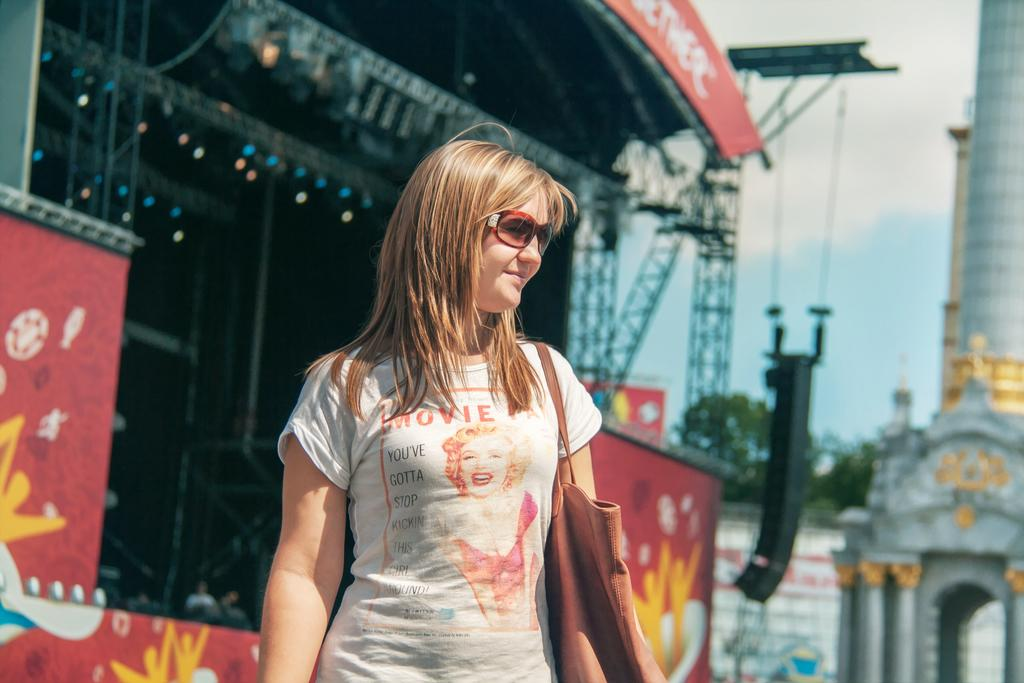Who is present in the image? There is a woman in the image. What is the woman holding or carrying? The woman is carrying a bag. What is the woman's facial expression? The woman is smiling. What can be seen in the background of the image? There is a stage, the sky, trees, and a wall visible in the background of the image. What type of straw is the woman using to take a bite of the apple in the image? There is no apple or straw present in the image; the woman is simply smiling and carrying a bag. 